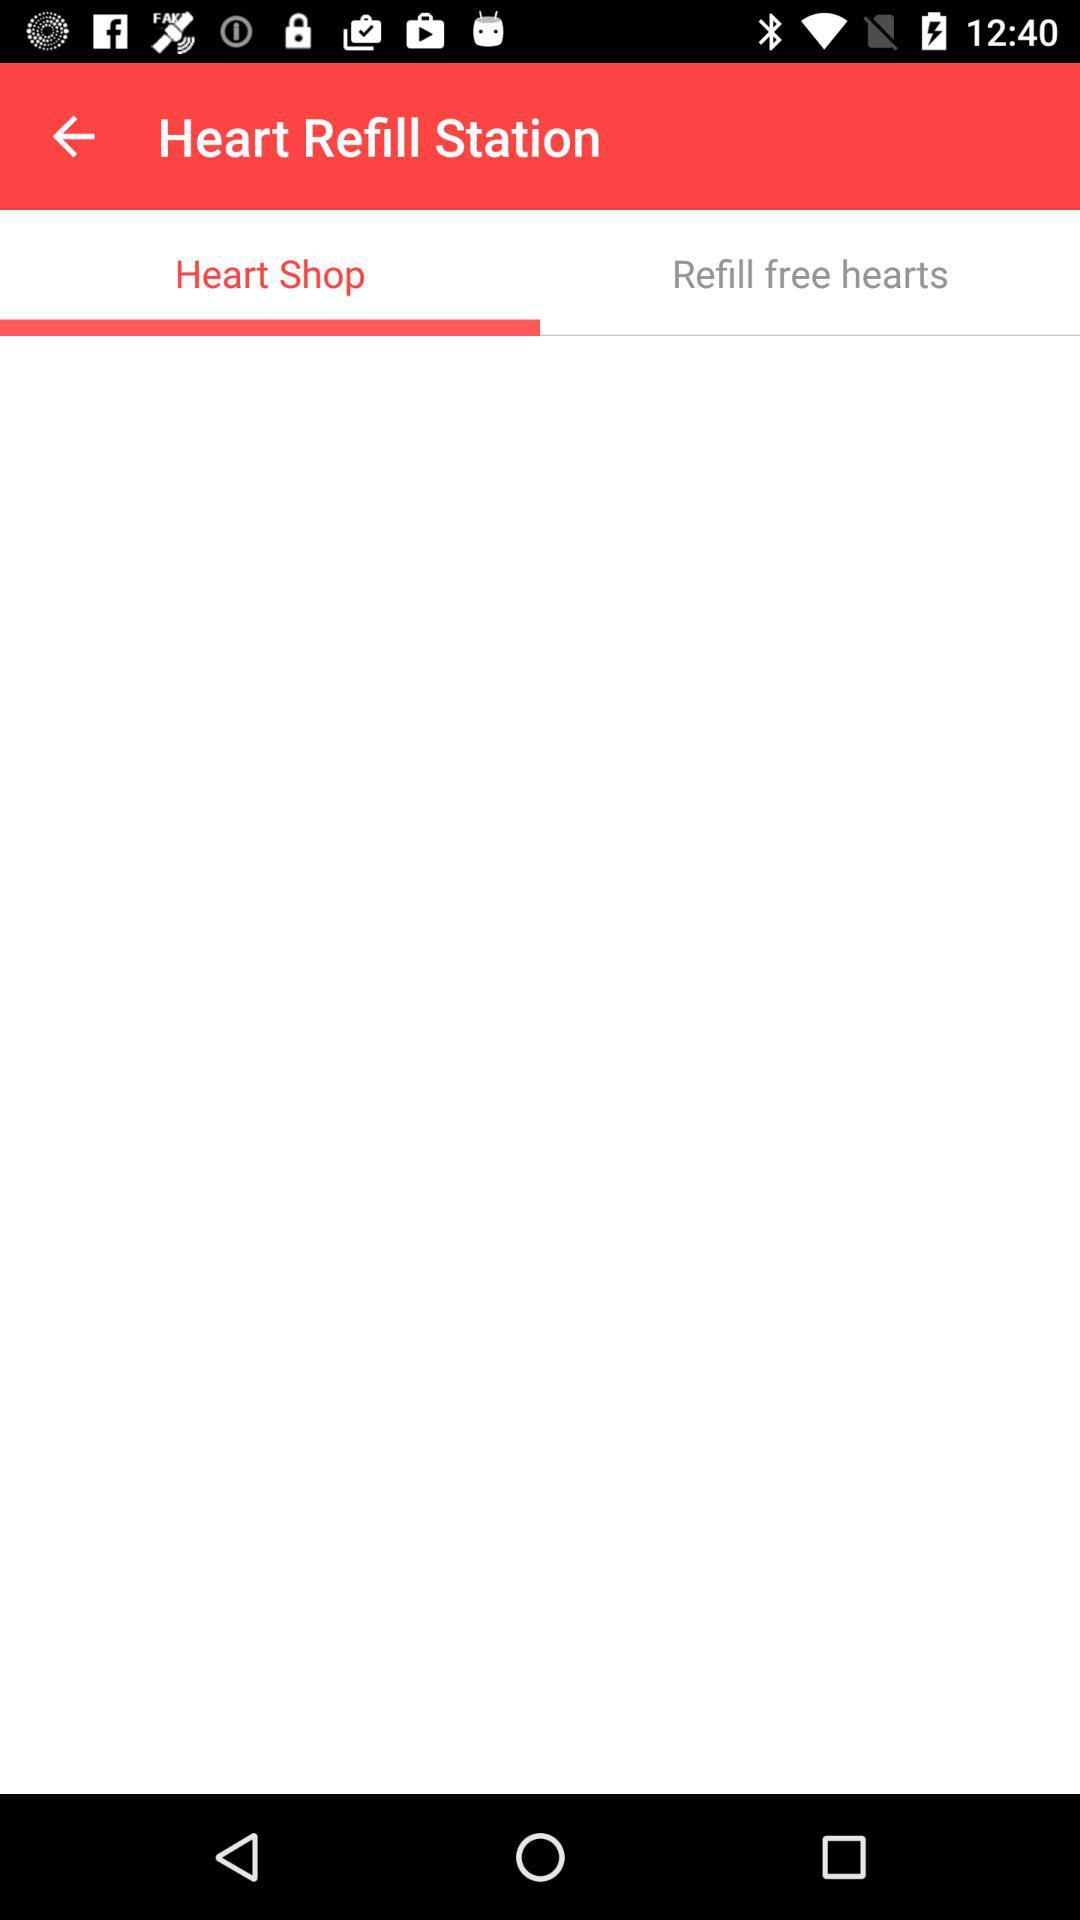Which tab is selected? The selected tab is Heat Shop. 